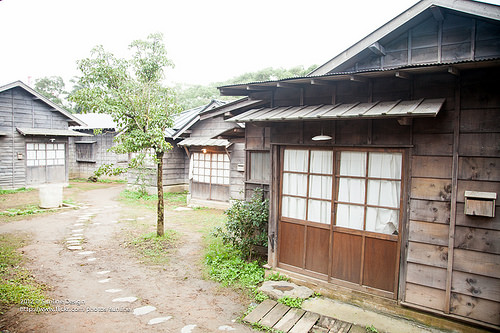<image>
Is there a house on the land? Yes. Looking at the image, I can see the house is positioned on top of the land, with the land providing support. 